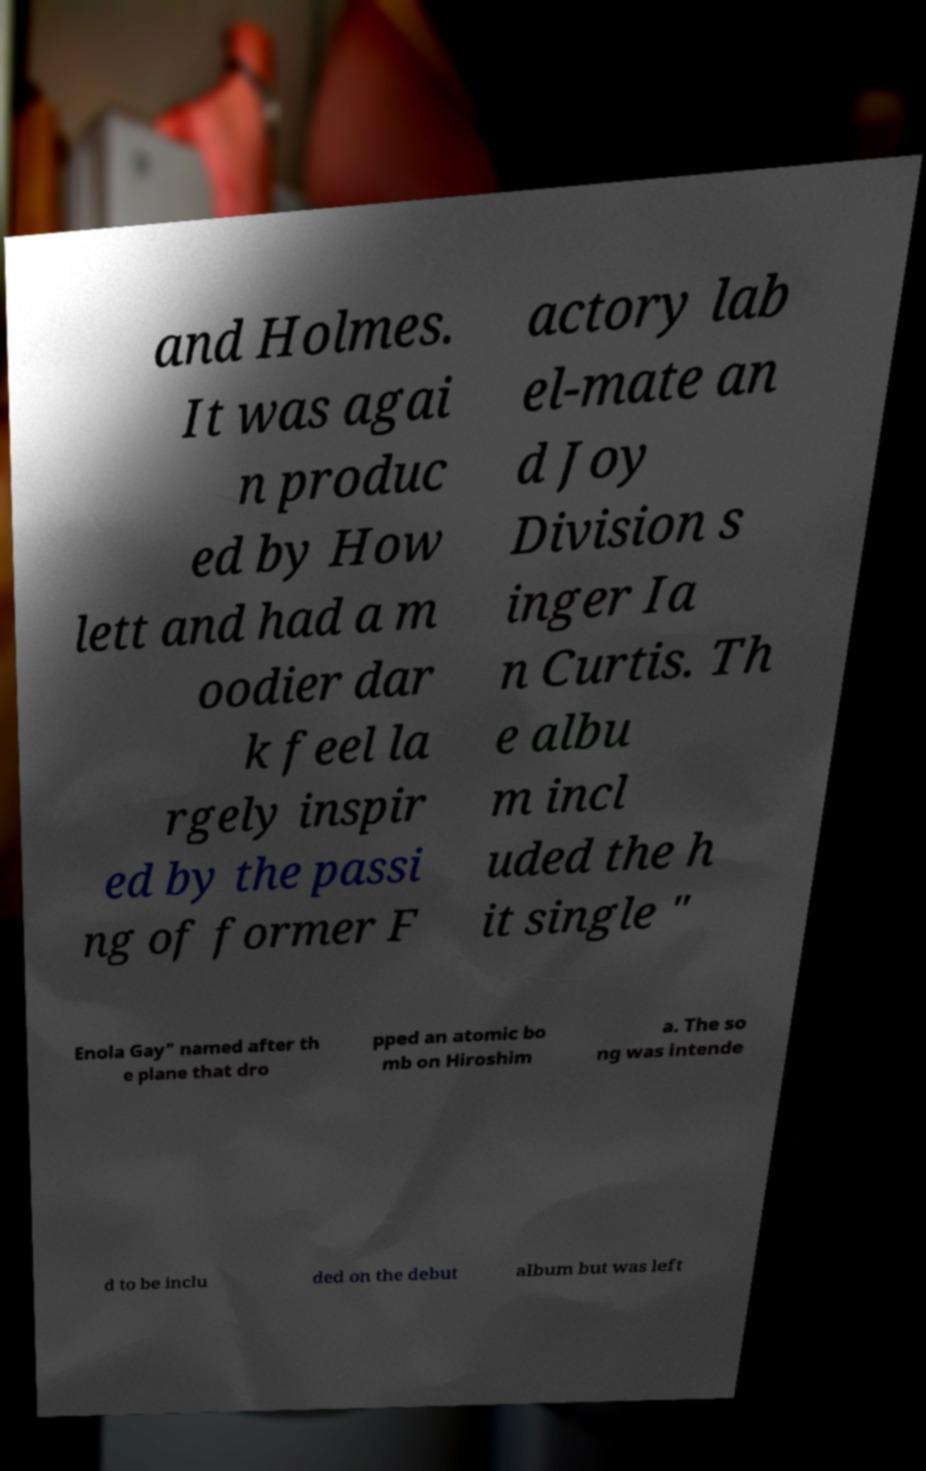Please read and relay the text visible in this image. What does it say? and Holmes. It was agai n produc ed by How lett and had a m oodier dar k feel la rgely inspir ed by the passi ng of former F actory lab el-mate an d Joy Division s inger Ia n Curtis. Th e albu m incl uded the h it single " Enola Gay" named after th e plane that dro pped an atomic bo mb on Hiroshim a. The so ng was intende d to be inclu ded on the debut album but was left 